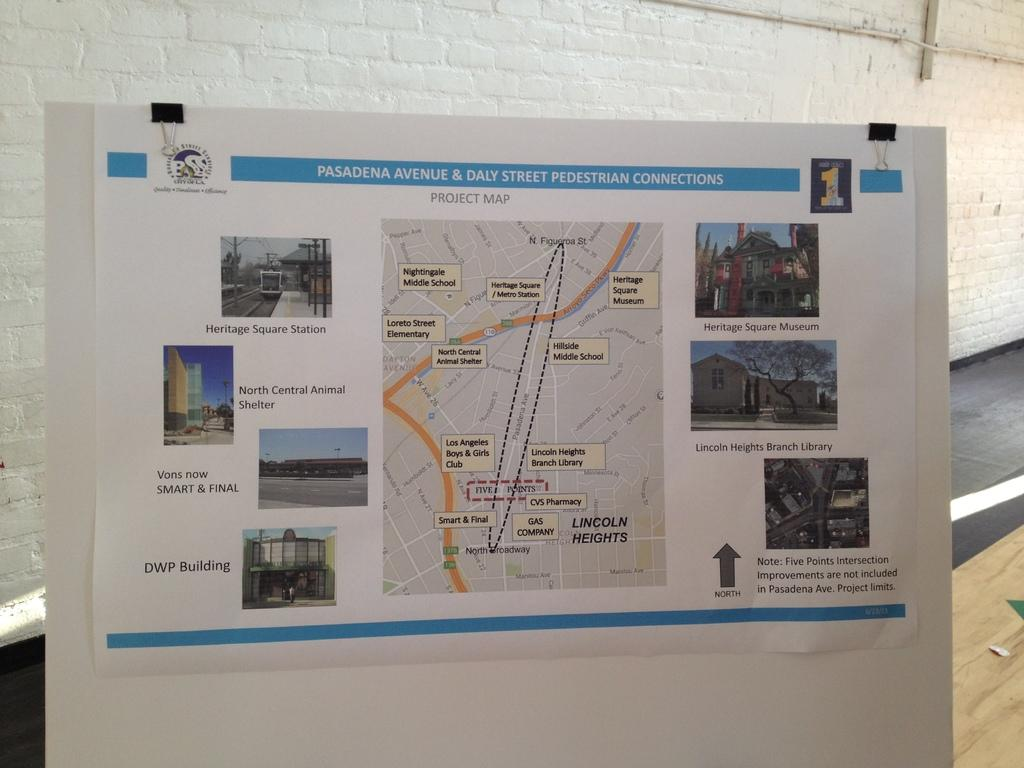<image>
Provide a brief description of the given image. Information is displayed about Pasadena Avenue and Daly Street. 